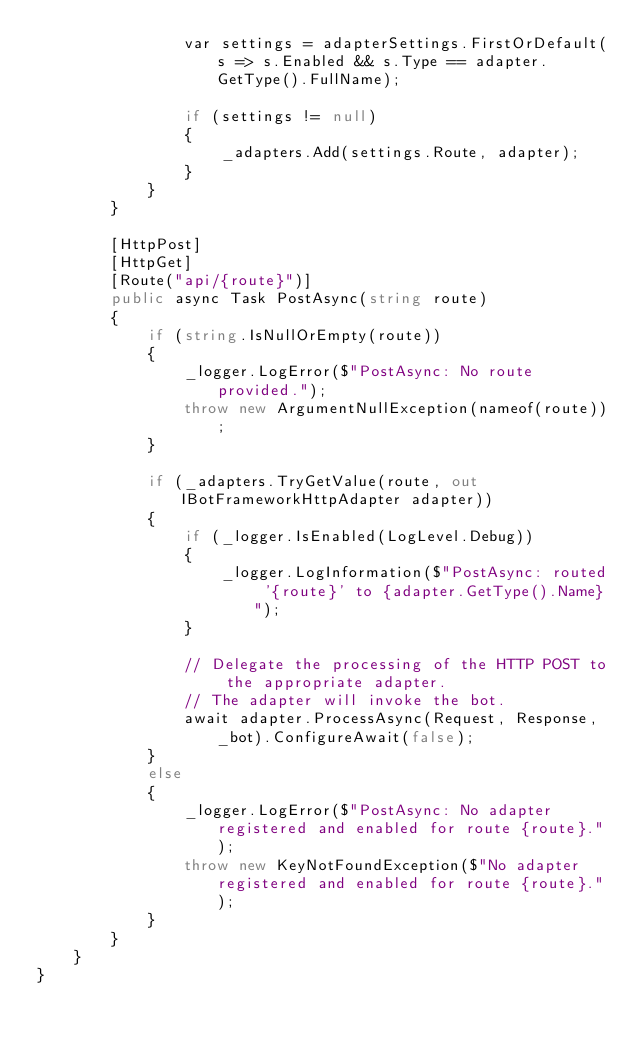<code> <loc_0><loc_0><loc_500><loc_500><_C#_>                var settings = adapterSettings.FirstOrDefault(s => s.Enabled && s.Type == adapter.GetType().FullName);

                if (settings != null)
                {
                    _adapters.Add(settings.Route, adapter);
                }
            }
        }

        [HttpPost]
        [HttpGet]
        [Route("api/{route}")]
        public async Task PostAsync(string route)
        {
            if (string.IsNullOrEmpty(route))
            {
                _logger.LogError($"PostAsync: No route provided.");
                throw new ArgumentNullException(nameof(route));
            }

            if (_adapters.TryGetValue(route, out IBotFrameworkHttpAdapter adapter))
            {
                if (_logger.IsEnabled(LogLevel.Debug))
                {
                    _logger.LogInformation($"PostAsync: routed '{route}' to {adapter.GetType().Name}");
                }

                // Delegate the processing of the HTTP POST to the appropriate adapter.
                // The adapter will invoke the bot.
                await adapter.ProcessAsync(Request, Response, _bot).ConfigureAwait(false);
            }
            else
            {
                _logger.LogError($"PostAsync: No adapter registered and enabled for route {route}.");
                throw new KeyNotFoundException($"No adapter registered and enabled for route {route}.");
            }
        }
    }
}
</code> 